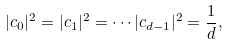<formula> <loc_0><loc_0><loc_500><loc_500>| c _ { 0 } | ^ { 2 } = | c _ { 1 } | ^ { 2 } = \cdots | c _ { d - 1 } | ^ { 2 } = \frac { 1 } { d } ,</formula> 